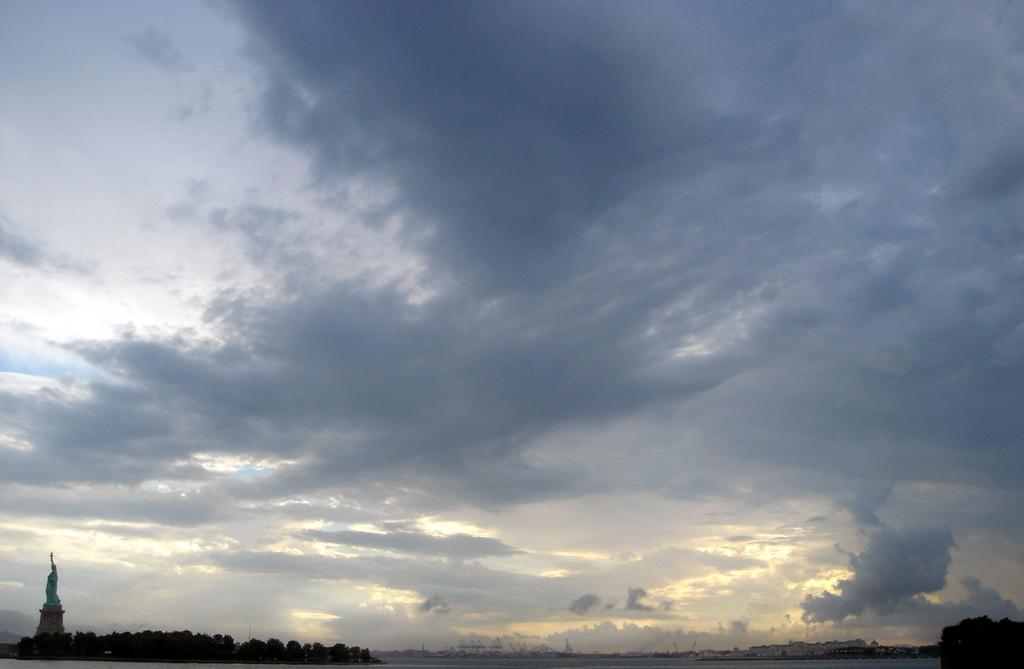What can be seen in the sky in the image? The sky with clouds is visible in the image. Where is the statue located in the image? The statue is in the bottom left of the image. What type of vegetation is present in the image? There are trees in the image. What type of structures can be seen in the background of the image? There are buildings in the background of the image. What shape is the window in the image? There is no window present in the image. What season is depicted in the image? The provided facts do not mention any specific season, so it cannot be determined from the image. 